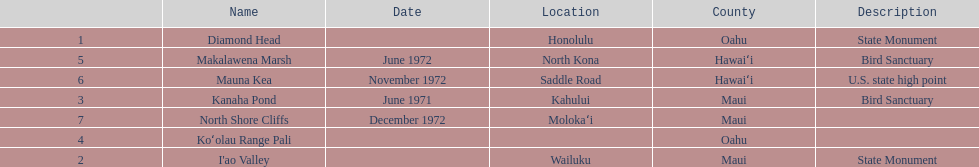How many locations are bird sanctuaries. 2. 